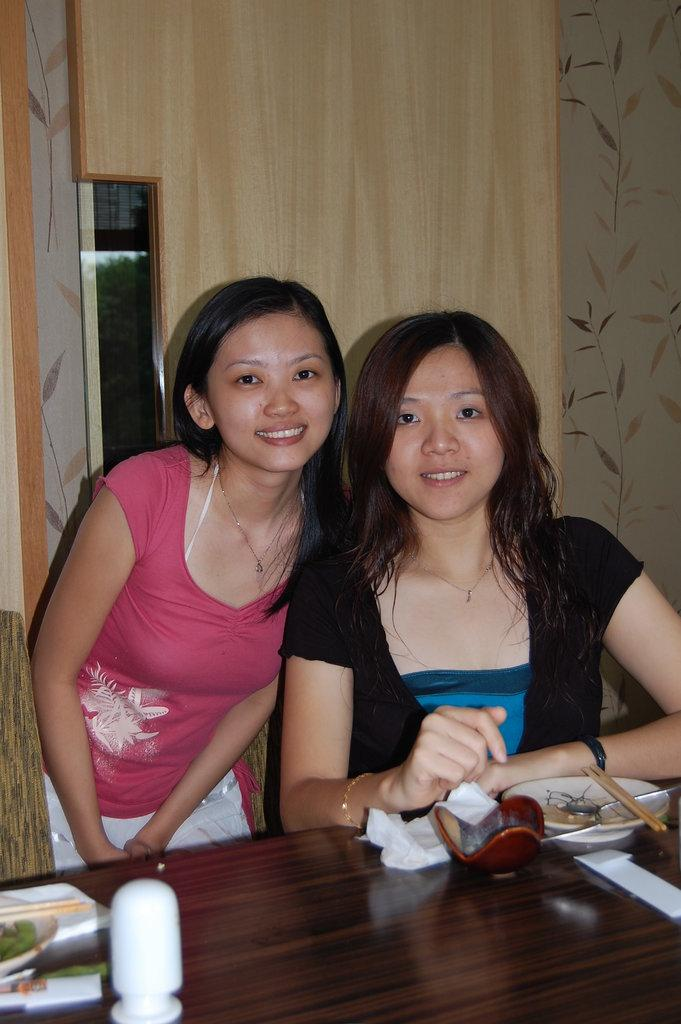How many women are in the image? There are two women in the image. What are the positions of the women in the image? One woman is sitting, and the other woman is standing beside the sitting woman. What is in front of the women? There is a table in front of the women. What type of flesh can be seen on the plate in the image? There is no plate or flesh present in the image. What things are the women discussing in the image? The image does not provide any information about what the women might be discussing. 